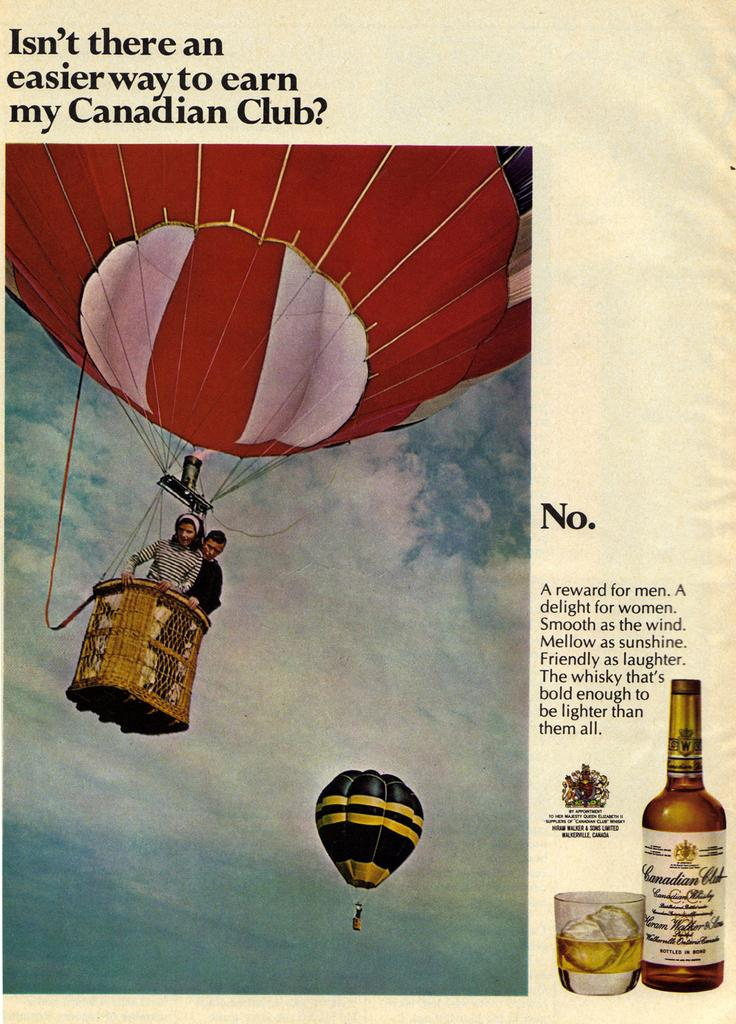<image>
Summarize the visual content of the image. An ad says Isn't there an easier way to earn my Canadian Club 